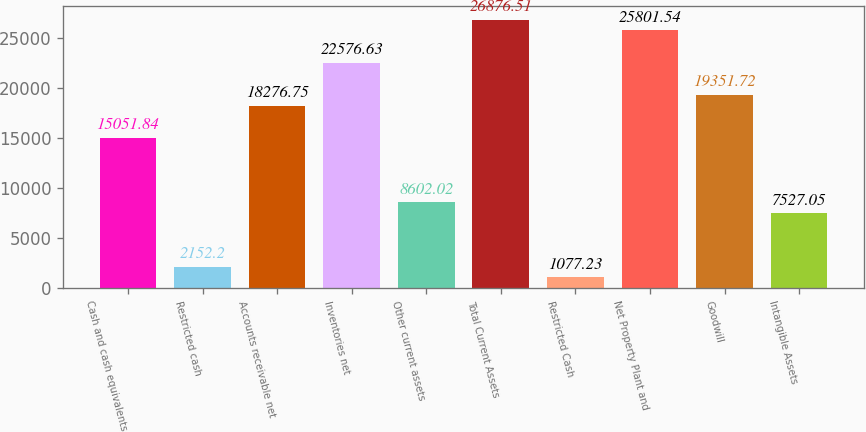Convert chart to OTSL. <chart><loc_0><loc_0><loc_500><loc_500><bar_chart><fcel>Cash and cash equivalents<fcel>Restricted cash<fcel>Accounts receivable net<fcel>Inventories net<fcel>Other current assets<fcel>Total Current Assets<fcel>Restricted Cash<fcel>Net Property Plant and<fcel>Goodwill<fcel>Intangible Assets<nl><fcel>15051.8<fcel>2152.2<fcel>18276.8<fcel>22576.6<fcel>8602.02<fcel>26876.5<fcel>1077.23<fcel>25801.5<fcel>19351.7<fcel>7527.05<nl></chart> 